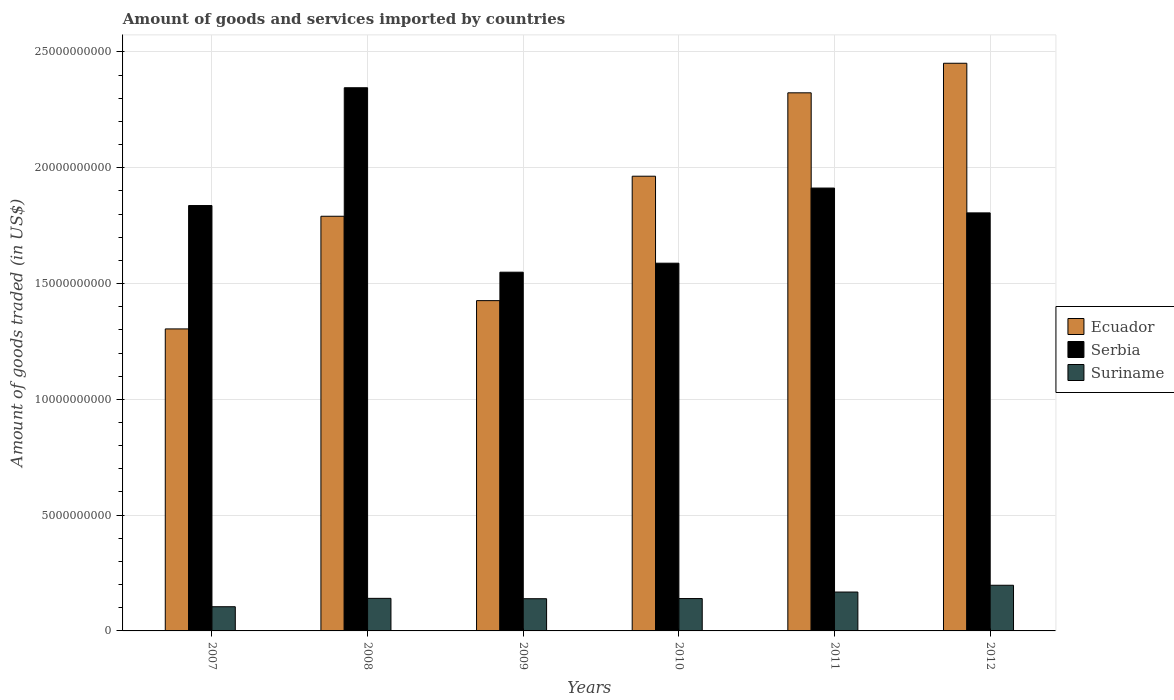Are the number of bars per tick equal to the number of legend labels?
Make the answer very short. Yes. Are the number of bars on each tick of the X-axis equal?
Keep it short and to the point. Yes. How many bars are there on the 5th tick from the left?
Offer a terse response. 3. What is the total amount of goods and services imported in Serbia in 2008?
Make the answer very short. 2.35e+1. Across all years, what is the maximum total amount of goods and services imported in Suriname?
Keep it short and to the point. 1.97e+09. Across all years, what is the minimum total amount of goods and services imported in Serbia?
Your answer should be compact. 1.55e+1. In which year was the total amount of goods and services imported in Ecuador minimum?
Your response must be concise. 2007. What is the total total amount of goods and services imported in Ecuador in the graph?
Your answer should be very brief. 1.13e+11. What is the difference between the total amount of goods and services imported in Suriname in 2010 and that in 2012?
Make the answer very short. -5.74e+08. What is the difference between the total amount of goods and services imported in Ecuador in 2011 and the total amount of goods and services imported in Suriname in 2010?
Offer a very short reply. 2.18e+1. What is the average total amount of goods and services imported in Ecuador per year?
Make the answer very short. 1.88e+1. In the year 2009, what is the difference between the total amount of goods and services imported in Suriname and total amount of goods and services imported in Ecuador?
Offer a terse response. -1.29e+1. In how many years, is the total amount of goods and services imported in Serbia greater than 16000000000 US$?
Make the answer very short. 4. What is the ratio of the total amount of goods and services imported in Ecuador in 2010 to that in 2012?
Provide a succinct answer. 0.8. Is the difference between the total amount of goods and services imported in Suriname in 2007 and 2010 greater than the difference between the total amount of goods and services imported in Ecuador in 2007 and 2010?
Make the answer very short. Yes. What is the difference between the highest and the second highest total amount of goods and services imported in Ecuador?
Make the answer very short. 1.28e+09. What is the difference between the highest and the lowest total amount of goods and services imported in Ecuador?
Your answer should be very brief. 1.15e+1. What does the 2nd bar from the left in 2007 represents?
Provide a succinct answer. Serbia. What does the 3rd bar from the right in 2010 represents?
Your answer should be compact. Ecuador. Are all the bars in the graph horizontal?
Give a very brief answer. No. What is the difference between two consecutive major ticks on the Y-axis?
Make the answer very short. 5.00e+09. Are the values on the major ticks of Y-axis written in scientific E-notation?
Your response must be concise. No. Does the graph contain any zero values?
Make the answer very short. No. Does the graph contain grids?
Your answer should be very brief. Yes. Where does the legend appear in the graph?
Your answer should be compact. Center right. How many legend labels are there?
Offer a very short reply. 3. How are the legend labels stacked?
Offer a very short reply. Vertical. What is the title of the graph?
Give a very brief answer. Amount of goods and services imported by countries. What is the label or title of the X-axis?
Keep it short and to the point. Years. What is the label or title of the Y-axis?
Provide a short and direct response. Amount of goods traded (in US$). What is the Amount of goods traded (in US$) in Ecuador in 2007?
Your answer should be compact. 1.30e+1. What is the Amount of goods traded (in US$) of Serbia in 2007?
Ensure brevity in your answer.  1.84e+1. What is the Amount of goods traded (in US$) in Suriname in 2007?
Your answer should be very brief. 1.04e+09. What is the Amount of goods traded (in US$) in Ecuador in 2008?
Your answer should be very brief. 1.79e+1. What is the Amount of goods traded (in US$) of Serbia in 2008?
Provide a short and direct response. 2.35e+1. What is the Amount of goods traded (in US$) in Suriname in 2008?
Ensure brevity in your answer.  1.41e+09. What is the Amount of goods traded (in US$) of Ecuador in 2009?
Provide a succinct answer. 1.43e+1. What is the Amount of goods traded (in US$) in Serbia in 2009?
Your answer should be very brief. 1.55e+1. What is the Amount of goods traded (in US$) of Suriname in 2009?
Your response must be concise. 1.39e+09. What is the Amount of goods traded (in US$) of Ecuador in 2010?
Give a very brief answer. 1.96e+1. What is the Amount of goods traded (in US$) of Serbia in 2010?
Ensure brevity in your answer.  1.59e+1. What is the Amount of goods traded (in US$) of Suriname in 2010?
Your answer should be compact. 1.40e+09. What is the Amount of goods traded (in US$) in Ecuador in 2011?
Make the answer very short. 2.32e+1. What is the Amount of goods traded (in US$) in Serbia in 2011?
Your answer should be compact. 1.91e+1. What is the Amount of goods traded (in US$) of Suriname in 2011?
Provide a short and direct response. 1.68e+09. What is the Amount of goods traded (in US$) of Ecuador in 2012?
Make the answer very short. 2.45e+1. What is the Amount of goods traded (in US$) in Serbia in 2012?
Give a very brief answer. 1.81e+1. What is the Amount of goods traded (in US$) in Suriname in 2012?
Make the answer very short. 1.97e+09. Across all years, what is the maximum Amount of goods traded (in US$) in Ecuador?
Offer a terse response. 2.45e+1. Across all years, what is the maximum Amount of goods traded (in US$) of Serbia?
Offer a very short reply. 2.35e+1. Across all years, what is the maximum Amount of goods traded (in US$) in Suriname?
Your answer should be very brief. 1.97e+09. Across all years, what is the minimum Amount of goods traded (in US$) in Ecuador?
Your answer should be very brief. 1.30e+1. Across all years, what is the minimum Amount of goods traded (in US$) of Serbia?
Offer a terse response. 1.55e+1. Across all years, what is the minimum Amount of goods traded (in US$) in Suriname?
Offer a very short reply. 1.04e+09. What is the total Amount of goods traded (in US$) of Ecuador in the graph?
Offer a very short reply. 1.13e+11. What is the total Amount of goods traded (in US$) in Serbia in the graph?
Offer a terse response. 1.10e+11. What is the total Amount of goods traded (in US$) of Suriname in the graph?
Your answer should be very brief. 8.89e+09. What is the difference between the Amount of goods traded (in US$) in Ecuador in 2007 and that in 2008?
Provide a succinct answer. -4.86e+09. What is the difference between the Amount of goods traded (in US$) of Serbia in 2007 and that in 2008?
Give a very brief answer. -5.09e+09. What is the difference between the Amount of goods traded (in US$) in Suriname in 2007 and that in 2008?
Ensure brevity in your answer.  -3.62e+08. What is the difference between the Amount of goods traded (in US$) of Ecuador in 2007 and that in 2009?
Your response must be concise. -1.22e+09. What is the difference between the Amount of goods traded (in US$) in Serbia in 2007 and that in 2009?
Provide a succinct answer. 2.88e+09. What is the difference between the Amount of goods traded (in US$) in Suriname in 2007 and that in 2009?
Keep it short and to the point. -3.46e+08. What is the difference between the Amount of goods traded (in US$) in Ecuador in 2007 and that in 2010?
Provide a succinct answer. -6.59e+09. What is the difference between the Amount of goods traded (in US$) in Serbia in 2007 and that in 2010?
Make the answer very short. 2.49e+09. What is the difference between the Amount of goods traded (in US$) of Suriname in 2007 and that in 2010?
Ensure brevity in your answer.  -3.53e+08. What is the difference between the Amount of goods traded (in US$) in Ecuador in 2007 and that in 2011?
Provide a succinct answer. -1.02e+1. What is the difference between the Amount of goods traded (in US$) of Serbia in 2007 and that in 2011?
Ensure brevity in your answer.  -7.55e+08. What is the difference between the Amount of goods traded (in US$) of Suriname in 2007 and that in 2011?
Your answer should be compact. -6.34e+08. What is the difference between the Amount of goods traded (in US$) of Ecuador in 2007 and that in 2012?
Ensure brevity in your answer.  -1.15e+1. What is the difference between the Amount of goods traded (in US$) of Serbia in 2007 and that in 2012?
Your response must be concise. 3.17e+08. What is the difference between the Amount of goods traded (in US$) in Suriname in 2007 and that in 2012?
Offer a terse response. -9.27e+08. What is the difference between the Amount of goods traded (in US$) in Ecuador in 2008 and that in 2009?
Make the answer very short. 3.64e+09. What is the difference between the Amount of goods traded (in US$) in Serbia in 2008 and that in 2009?
Your response must be concise. 7.96e+09. What is the difference between the Amount of goods traded (in US$) in Suriname in 2008 and that in 2009?
Make the answer very short. 1.60e+07. What is the difference between the Amount of goods traded (in US$) of Ecuador in 2008 and that in 2010?
Your answer should be compact. -1.73e+09. What is the difference between the Amount of goods traded (in US$) in Serbia in 2008 and that in 2010?
Your answer should be very brief. 7.58e+09. What is the difference between the Amount of goods traded (in US$) of Suriname in 2008 and that in 2010?
Offer a very short reply. 8.80e+06. What is the difference between the Amount of goods traded (in US$) in Ecuador in 2008 and that in 2011?
Keep it short and to the point. -5.33e+09. What is the difference between the Amount of goods traded (in US$) of Serbia in 2008 and that in 2011?
Provide a short and direct response. 4.33e+09. What is the difference between the Amount of goods traded (in US$) in Suriname in 2008 and that in 2011?
Your answer should be very brief. -2.72e+08. What is the difference between the Amount of goods traded (in US$) in Ecuador in 2008 and that in 2012?
Provide a short and direct response. -6.61e+09. What is the difference between the Amount of goods traded (in US$) of Serbia in 2008 and that in 2012?
Offer a terse response. 5.40e+09. What is the difference between the Amount of goods traded (in US$) in Suriname in 2008 and that in 2012?
Ensure brevity in your answer.  -5.65e+08. What is the difference between the Amount of goods traded (in US$) of Ecuador in 2009 and that in 2010?
Offer a terse response. -5.37e+09. What is the difference between the Amount of goods traded (in US$) of Serbia in 2009 and that in 2010?
Your answer should be compact. -3.89e+08. What is the difference between the Amount of goods traded (in US$) in Suriname in 2009 and that in 2010?
Give a very brief answer. -7.20e+06. What is the difference between the Amount of goods traded (in US$) of Ecuador in 2009 and that in 2011?
Ensure brevity in your answer.  -8.97e+09. What is the difference between the Amount of goods traded (in US$) in Serbia in 2009 and that in 2011?
Provide a succinct answer. -3.63e+09. What is the difference between the Amount of goods traded (in US$) of Suriname in 2009 and that in 2011?
Offer a very short reply. -2.88e+08. What is the difference between the Amount of goods traded (in US$) in Ecuador in 2009 and that in 2012?
Provide a succinct answer. -1.03e+1. What is the difference between the Amount of goods traded (in US$) in Serbia in 2009 and that in 2012?
Offer a terse response. -2.56e+09. What is the difference between the Amount of goods traded (in US$) in Suriname in 2009 and that in 2012?
Make the answer very short. -5.81e+08. What is the difference between the Amount of goods traded (in US$) of Ecuador in 2010 and that in 2011?
Provide a short and direct response. -3.60e+09. What is the difference between the Amount of goods traded (in US$) of Serbia in 2010 and that in 2011?
Your response must be concise. -3.24e+09. What is the difference between the Amount of goods traded (in US$) of Suriname in 2010 and that in 2011?
Your answer should be very brief. -2.81e+08. What is the difference between the Amount of goods traded (in US$) of Ecuador in 2010 and that in 2012?
Offer a terse response. -4.88e+09. What is the difference between the Amount of goods traded (in US$) of Serbia in 2010 and that in 2012?
Offer a very short reply. -2.17e+09. What is the difference between the Amount of goods traded (in US$) of Suriname in 2010 and that in 2012?
Offer a very short reply. -5.74e+08. What is the difference between the Amount of goods traded (in US$) of Ecuador in 2011 and that in 2012?
Give a very brief answer. -1.28e+09. What is the difference between the Amount of goods traded (in US$) of Serbia in 2011 and that in 2012?
Provide a succinct answer. 1.07e+09. What is the difference between the Amount of goods traded (in US$) in Suriname in 2011 and that in 2012?
Your answer should be compact. -2.92e+08. What is the difference between the Amount of goods traded (in US$) of Ecuador in 2007 and the Amount of goods traded (in US$) of Serbia in 2008?
Provide a short and direct response. -1.04e+1. What is the difference between the Amount of goods traded (in US$) in Ecuador in 2007 and the Amount of goods traded (in US$) in Suriname in 2008?
Give a very brief answer. 1.16e+1. What is the difference between the Amount of goods traded (in US$) in Serbia in 2007 and the Amount of goods traded (in US$) in Suriname in 2008?
Your answer should be compact. 1.70e+1. What is the difference between the Amount of goods traded (in US$) of Ecuador in 2007 and the Amount of goods traded (in US$) of Serbia in 2009?
Ensure brevity in your answer.  -2.45e+09. What is the difference between the Amount of goods traded (in US$) in Ecuador in 2007 and the Amount of goods traded (in US$) in Suriname in 2009?
Keep it short and to the point. 1.17e+1. What is the difference between the Amount of goods traded (in US$) of Serbia in 2007 and the Amount of goods traded (in US$) of Suriname in 2009?
Make the answer very short. 1.70e+1. What is the difference between the Amount of goods traded (in US$) in Ecuador in 2007 and the Amount of goods traded (in US$) in Serbia in 2010?
Offer a terse response. -2.84e+09. What is the difference between the Amount of goods traded (in US$) of Ecuador in 2007 and the Amount of goods traded (in US$) of Suriname in 2010?
Make the answer very short. 1.16e+1. What is the difference between the Amount of goods traded (in US$) of Serbia in 2007 and the Amount of goods traded (in US$) of Suriname in 2010?
Make the answer very short. 1.70e+1. What is the difference between the Amount of goods traded (in US$) in Ecuador in 2007 and the Amount of goods traded (in US$) in Serbia in 2011?
Your response must be concise. -6.08e+09. What is the difference between the Amount of goods traded (in US$) in Ecuador in 2007 and the Amount of goods traded (in US$) in Suriname in 2011?
Your answer should be very brief. 1.14e+1. What is the difference between the Amount of goods traded (in US$) of Serbia in 2007 and the Amount of goods traded (in US$) of Suriname in 2011?
Your answer should be very brief. 1.67e+1. What is the difference between the Amount of goods traded (in US$) of Ecuador in 2007 and the Amount of goods traded (in US$) of Serbia in 2012?
Make the answer very short. -5.01e+09. What is the difference between the Amount of goods traded (in US$) in Ecuador in 2007 and the Amount of goods traded (in US$) in Suriname in 2012?
Offer a very short reply. 1.11e+1. What is the difference between the Amount of goods traded (in US$) in Serbia in 2007 and the Amount of goods traded (in US$) in Suriname in 2012?
Offer a very short reply. 1.64e+1. What is the difference between the Amount of goods traded (in US$) in Ecuador in 2008 and the Amount of goods traded (in US$) in Serbia in 2009?
Offer a terse response. 2.42e+09. What is the difference between the Amount of goods traded (in US$) in Ecuador in 2008 and the Amount of goods traded (in US$) in Suriname in 2009?
Ensure brevity in your answer.  1.65e+1. What is the difference between the Amount of goods traded (in US$) in Serbia in 2008 and the Amount of goods traded (in US$) in Suriname in 2009?
Keep it short and to the point. 2.21e+1. What is the difference between the Amount of goods traded (in US$) of Ecuador in 2008 and the Amount of goods traded (in US$) of Serbia in 2010?
Your response must be concise. 2.03e+09. What is the difference between the Amount of goods traded (in US$) of Ecuador in 2008 and the Amount of goods traded (in US$) of Suriname in 2010?
Offer a very short reply. 1.65e+1. What is the difference between the Amount of goods traded (in US$) in Serbia in 2008 and the Amount of goods traded (in US$) in Suriname in 2010?
Your answer should be very brief. 2.21e+1. What is the difference between the Amount of goods traded (in US$) in Ecuador in 2008 and the Amount of goods traded (in US$) in Serbia in 2011?
Keep it short and to the point. -1.22e+09. What is the difference between the Amount of goods traded (in US$) in Ecuador in 2008 and the Amount of goods traded (in US$) in Suriname in 2011?
Your response must be concise. 1.62e+1. What is the difference between the Amount of goods traded (in US$) in Serbia in 2008 and the Amount of goods traded (in US$) in Suriname in 2011?
Your answer should be very brief. 2.18e+1. What is the difference between the Amount of goods traded (in US$) of Ecuador in 2008 and the Amount of goods traded (in US$) of Serbia in 2012?
Your answer should be compact. -1.46e+08. What is the difference between the Amount of goods traded (in US$) in Ecuador in 2008 and the Amount of goods traded (in US$) in Suriname in 2012?
Your response must be concise. 1.59e+1. What is the difference between the Amount of goods traded (in US$) of Serbia in 2008 and the Amount of goods traded (in US$) of Suriname in 2012?
Make the answer very short. 2.15e+1. What is the difference between the Amount of goods traded (in US$) in Ecuador in 2009 and the Amount of goods traded (in US$) in Serbia in 2010?
Make the answer very short. -1.62e+09. What is the difference between the Amount of goods traded (in US$) in Ecuador in 2009 and the Amount of goods traded (in US$) in Suriname in 2010?
Your answer should be compact. 1.29e+1. What is the difference between the Amount of goods traded (in US$) of Serbia in 2009 and the Amount of goods traded (in US$) of Suriname in 2010?
Your answer should be compact. 1.41e+1. What is the difference between the Amount of goods traded (in US$) of Ecuador in 2009 and the Amount of goods traded (in US$) of Serbia in 2011?
Your answer should be compact. -4.86e+09. What is the difference between the Amount of goods traded (in US$) in Ecuador in 2009 and the Amount of goods traded (in US$) in Suriname in 2011?
Offer a terse response. 1.26e+1. What is the difference between the Amount of goods traded (in US$) of Serbia in 2009 and the Amount of goods traded (in US$) of Suriname in 2011?
Your answer should be very brief. 1.38e+1. What is the difference between the Amount of goods traded (in US$) in Ecuador in 2009 and the Amount of goods traded (in US$) in Serbia in 2012?
Provide a short and direct response. -3.79e+09. What is the difference between the Amount of goods traded (in US$) of Ecuador in 2009 and the Amount of goods traded (in US$) of Suriname in 2012?
Give a very brief answer. 1.23e+1. What is the difference between the Amount of goods traded (in US$) of Serbia in 2009 and the Amount of goods traded (in US$) of Suriname in 2012?
Keep it short and to the point. 1.35e+1. What is the difference between the Amount of goods traded (in US$) in Ecuador in 2010 and the Amount of goods traded (in US$) in Serbia in 2011?
Keep it short and to the point. 5.11e+08. What is the difference between the Amount of goods traded (in US$) of Ecuador in 2010 and the Amount of goods traded (in US$) of Suriname in 2011?
Your answer should be compact. 1.80e+1. What is the difference between the Amount of goods traded (in US$) in Serbia in 2010 and the Amount of goods traded (in US$) in Suriname in 2011?
Your response must be concise. 1.42e+1. What is the difference between the Amount of goods traded (in US$) in Ecuador in 2010 and the Amount of goods traded (in US$) in Serbia in 2012?
Ensure brevity in your answer.  1.58e+09. What is the difference between the Amount of goods traded (in US$) in Ecuador in 2010 and the Amount of goods traded (in US$) in Suriname in 2012?
Offer a very short reply. 1.77e+1. What is the difference between the Amount of goods traded (in US$) of Serbia in 2010 and the Amount of goods traded (in US$) of Suriname in 2012?
Give a very brief answer. 1.39e+1. What is the difference between the Amount of goods traded (in US$) of Ecuador in 2011 and the Amount of goods traded (in US$) of Serbia in 2012?
Give a very brief answer. 5.18e+09. What is the difference between the Amount of goods traded (in US$) of Ecuador in 2011 and the Amount of goods traded (in US$) of Suriname in 2012?
Your answer should be very brief. 2.13e+1. What is the difference between the Amount of goods traded (in US$) of Serbia in 2011 and the Amount of goods traded (in US$) of Suriname in 2012?
Give a very brief answer. 1.72e+1. What is the average Amount of goods traded (in US$) of Ecuador per year?
Make the answer very short. 1.88e+1. What is the average Amount of goods traded (in US$) in Serbia per year?
Provide a short and direct response. 1.84e+1. What is the average Amount of goods traded (in US$) in Suriname per year?
Your response must be concise. 1.48e+09. In the year 2007, what is the difference between the Amount of goods traded (in US$) of Ecuador and Amount of goods traded (in US$) of Serbia?
Offer a terse response. -5.33e+09. In the year 2007, what is the difference between the Amount of goods traded (in US$) in Ecuador and Amount of goods traded (in US$) in Suriname?
Provide a succinct answer. 1.20e+1. In the year 2007, what is the difference between the Amount of goods traded (in US$) of Serbia and Amount of goods traded (in US$) of Suriname?
Provide a short and direct response. 1.73e+1. In the year 2008, what is the difference between the Amount of goods traded (in US$) of Ecuador and Amount of goods traded (in US$) of Serbia?
Provide a short and direct response. -5.55e+09. In the year 2008, what is the difference between the Amount of goods traded (in US$) of Ecuador and Amount of goods traded (in US$) of Suriname?
Keep it short and to the point. 1.65e+1. In the year 2008, what is the difference between the Amount of goods traded (in US$) of Serbia and Amount of goods traded (in US$) of Suriname?
Ensure brevity in your answer.  2.20e+1. In the year 2009, what is the difference between the Amount of goods traded (in US$) of Ecuador and Amount of goods traded (in US$) of Serbia?
Ensure brevity in your answer.  -1.23e+09. In the year 2009, what is the difference between the Amount of goods traded (in US$) of Ecuador and Amount of goods traded (in US$) of Suriname?
Provide a succinct answer. 1.29e+1. In the year 2009, what is the difference between the Amount of goods traded (in US$) of Serbia and Amount of goods traded (in US$) of Suriname?
Provide a succinct answer. 1.41e+1. In the year 2010, what is the difference between the Amount of goods traded (in US$) of Ecuador and Amount of goods traded (in US$) of Serbia?
Provide a succinct answer. 3.76e+09. In the year 2010, what is the difference between the Amount of goods traded (in US$) in Ecuador and Amount of goods traded (in US$) in Suriname?
Provide a succinct answer. 1.82e+1. In the year 2010, what is the difference between the Amount of goods traded (in US$) in Serbia and Amount of goods traded (in US$) in Suriname?
Provide a short and direct response. 1.45e+1. In the year 2011, what is the difference between the Amount of goods traded (in US$) of Ecuador and Amount of goods traded (in US$) of Serbia?
Provide a short and direct response. 4.11e+09. In the year 2011, what is the difference between the Amount of goods traded (in US$) in Ecuador and Amount of goods traded (in US$) in Suriname?
Make the answer very short. 2.16e+1. In the year 2011, what is the difference between the Amount of goods traded (in US$) in Serbia and Amount of goods traded (in US$) in Suriname?
Provide a short and direct response. 1.74e+1. In the year 2012, what is the difference between the Amount of goods traded (in US$) of Ecuador and Amount of goods traded (in US$) of Serbia?
Ensure brevity in your answer.  6.46e+09. In the year 2012, what is the difference between the Amount of goods traded (in US$) in Ecuador and Amount of goods traded (in US$) in Suriname?
Your response must be concise. 2.25e+1. In the year 2012, what is the difference between the Amount of goods traded (in US$) of Serbia and Amount of goods traded (in US$) of Suriname?
Provide a succinct answer. 1.61e+1. What is the ratio of the Amount of goods traded (in US$) of Ecuador in 2007 to that in 2008?
Provide a succinct answer. 0.73. What is the ratio of the Amount of goods traded (in US$) of Serbia in 2007 to that in 2008?
Your answer should be compact. 0.78. What is the ratio of the Amount of goods traded (in US$) in Suriname in 2007 to that in 2008?
Your answer should be compact. 0.74. What is the ratio of the Amount of goods traded (in US$) of Ecuador in 2007 to that in 2009?
Provide a short and direct response. 0.91. What is the ratio of the Amount of goods traded (in US$) of Serbia in 2007 to that in 2009?
Give a very brief answer. 1.19. What is the ratio of the Amount of goods traded (in US$) in Suriname in 2007 to that in 2009?
Give a very brief answer. 0.75. What is the ratio of the Amount of goods traded (in US$) of Ecuador in 2007 to that in 2010?
Keep it short and to the point. 0.66. What is the ratio of the Amount of goods traded (in US$) of Serbia in 2007 to that in 2010?
Offer a very short reply. 1.16. What is the ratio of the Amount of goods traded (in US$) in Suriname in 2007 to that in 2010?
Your answer should be very brief. 0.75. What is the ratio of the Amount of goods traded (in US$) in Ecuador in 2007 to that in 2011?
Offer a terse response. 0.56. What is the ratio of the Amount of goods traded (in US$) in Serbia in 2007 to that in 2011?
Give a very brief answer. 0.96. What is the ratio of the Amount of goods traded (in US$) of Suriname in 2007 to that in 2011?
Offer a very short reply. 0.62. What is the ratio of the Amount of goods traded (in US$) of Ecuador in 2007 to that in 2012?
Ensure brevity in your answer.  0.53. What is the ratio of the Amount of goods traded (in US$) of Serbia in 2007 to that in 2012?
Your response must be concise. 1.02. What is the ratio of the Amount of goods traded (in US$) in Suriname in 2007 to that in 2012?
Your response must be concise. 0.53. What is the ratio of the Amount of goods traded (in US$) of Ecuador in 2008 to that in 2009?
Your answer should be compact. 1.26. What is the ratio of the Amount of goods traded (in US$) in Serbia in 2008 to that in 2009?
Your response must be concise. 1.51. What is the ratio of the Amount of goods traded (in US$) in Suriname in 2008 to that in 2009?
Provide a short and direct response. 1.01. What is the ratio of the Amount of goods traded (in US$) in Ecuador in 2008 to that in 2010?
Your answer should be very brief. 0.91. What is the ratio of the Amount of goods traded (in US$) in Serbia in 2008 to that in 2010?
Ensure brevity in your answer.  1.48. What is the ratio of the Amount of goods traded (in US$) in Suriname in 2008 to that in 2010?
Offer a terse response. 1.01. What is the ratio of the Amount of goods traded (in US$) of Ecuador in 2008 to that in 2011?
Make the answer very short. 0.77. What is the ratio of the Amount of goods traded (in US$) in Serbia in 2008 to that in 2011?
Offer a very short reply. 1.23. What is the ratio of the Amount of goods traded (in US$) in Suriname in 2008 to that in 2011?
Your answer should be compact. 0.84. What is the ratio of the Amount of goods traded (in US$) in Ecuador in 2008 to that in 2012?
Ensure brevity in your answer.  0.73. What is the ratio of the Amount of goods traded (in US$) in Serbia in 2008 to that in 2012?
Ensure brevity in your answer.  1.3. What is the ratio of the Amount of goods traded (in US$) of Suriname in 2008 to that in 2012?
Your answer should be very brief. 0.71. What is the ratio of the Amount of goods traded (in US$) of Ecuador in 2009 to that in 2010?
Your response must be concise. 0.73. What is the ratio of the Amount of goods traded (in US$) in Serbia in 2009 to that in 2010?
Provide a succinct answer. 0.98. What is the ratio of the Amount of goods traded (in US$) of Ecuador in 2009 to that in 2011?
Offer a very short reply. 0.61. What is the ratio of the Amount of goods traded (in US$) of Serbia in 2009 to that in 2011?
Keep it short and to the point. 0.81. What is the ratio of the Amount of goods traded (in US$) in Suriname in 2009 to that in 2011?
Your answer should be compact. 0.83. What is the ratio of the Amount of goods traded (in US$) of Ecuador in 2009 to that in 2012?
Your answer should be very brief. 0.58. What is the ratio of the Amount of goods traded (in US$) of Serbia in 2009 to that in 2012?
Keep it short and to the point. 0.86. What is the ratio of the Amount of goods traded (in US$) of Suriname in 2009 to that in 2012?
Provide a succinct answer. 0.71. What is the ratio of the Amount of goods traded (in US$) of Ecuador in 2010 to that in 2011?
Your answer should be very brief. 0.84. What is the ratio of the Amount of goods traded (in US$) of Serbia in 2010 to that in 2011?
Offer a very short reply. 0.83. What is the ratio of the Amount of goods traded (in US$) of Suriname in 2010 to that in 2011?
Provide a short and direct response. 0.83. What is the ratio of the Amount of goods traded (in US$) in Ecuador in 2010 to that in 2012?
Your answer should be very brief. 0.8. What is the ratio of the Amount of goods traded (in US$) of Serbia in 2010 to that in 2012?
Offer a very short reply. 0.88. What is the ratio of the Amount of goods traded (in US$) of Suriname in 2010 to that in 2012?
Your answer should be compact. 0.71. What is the ratio of the Amount of goods traded (in US$) of Ecuador in 2011 to that in 2012?
Your answer should be very brief. 0.95. What is the ratio of the Amount of goods traded (in US$) in Serbia in 2011 to that in 2012?
Ensure brevity in your answer.  1.06. What is the ratio of the Amount of goods traded (in US$) in Suriname in 2011 to that in 2012?
Ensure brevity in your answer.  0.85. What is the difference between the highest and the second highest Amount of goods traded (in US$) in Ecuador?
Offer a terse response. 1.28e+09. What is the difference between the highest and the second highest Amount of goods traded (in US$) of Serbia?
Provide a succinct answer. 4.33e+09. What is the difference between the highest and the second highest Amount of goods traded (in US$) in Suriname?
Your answer should be very brief. 2.92e+08. What is the difference between the highest and the lowest Amount of goods traded (in US$) in Ecuador?
Offer a terse response. 1.15e+1. What is the difference between the highest and the lowest Amount of goods traded (in US$) in Serbia?
Give a very brief answer. 7.96e+09. What is the difference between the highest and the lowest Amount of goods traded (in US$) of Suriname?
Make the answer very short. 9.27e+08. 